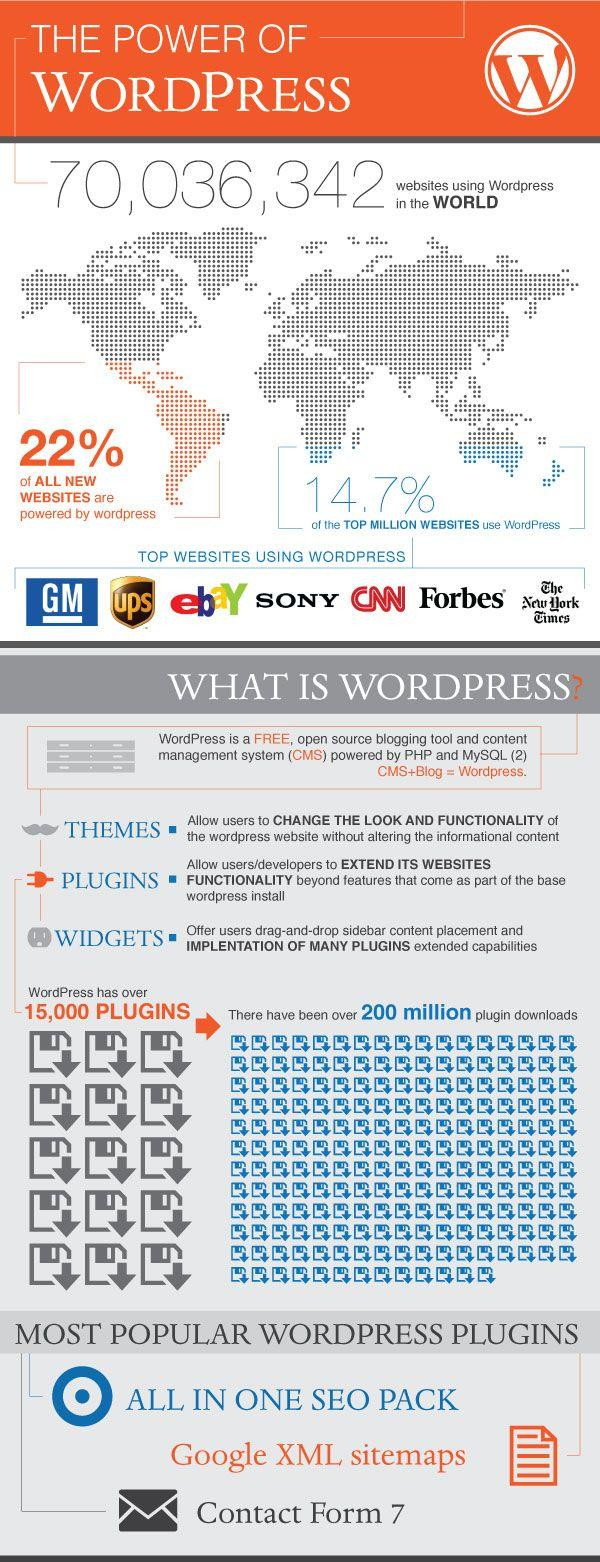Point out several critical features in this image. According to the infographic, WordPress is mentioned in 7 websites. According to a recent estimate, 78% of all new websites are not powered by WordPress. 